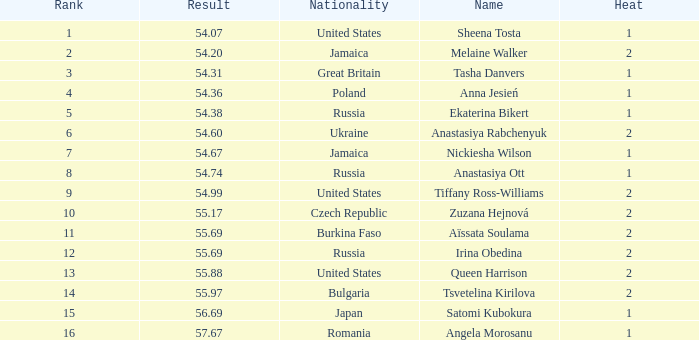Which Nationality has a Heat smaller than 2, and a Rank of 15? Japan. 